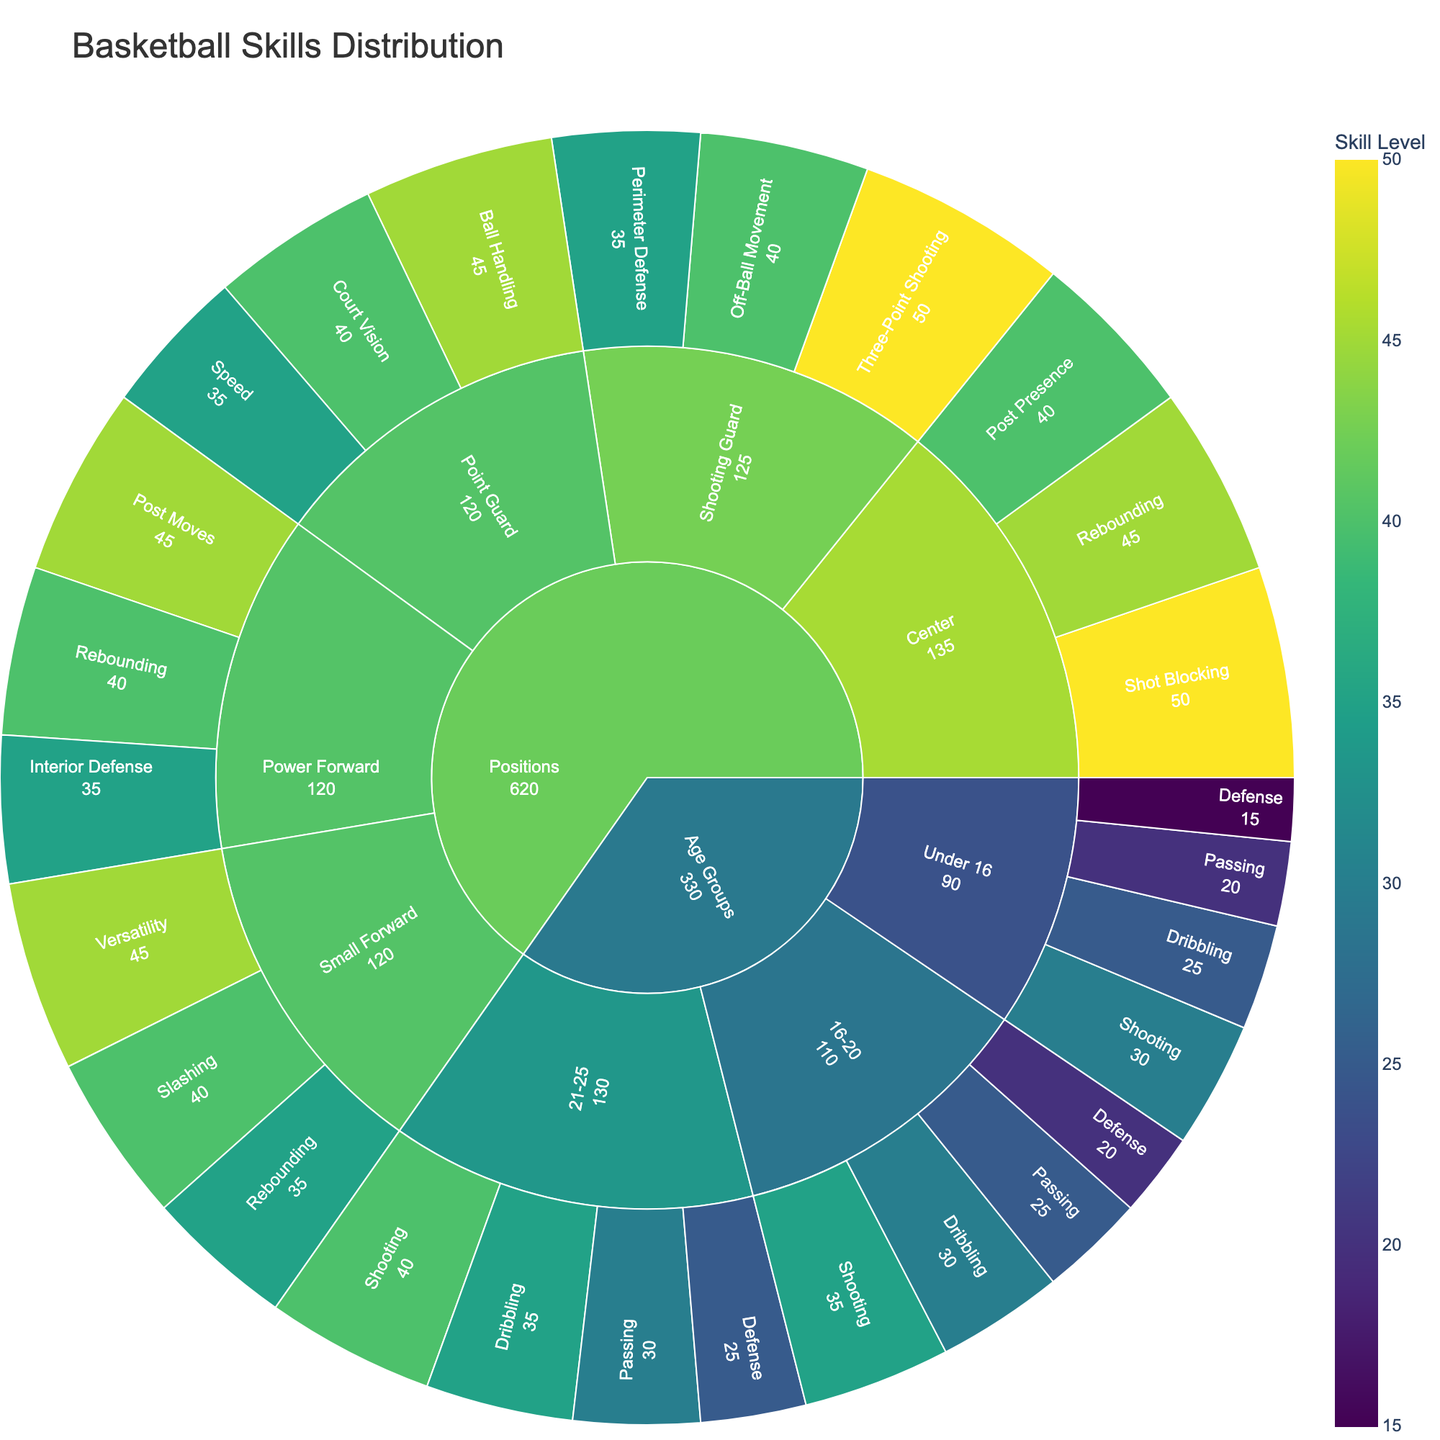what does the title of the plot indicate? The title of the plot says "Basketball Skills Distribution," which indicates that this plot provides information on how various basketball skills are distributed among players categorized by different age groups and positions.
Answer: Basketball Skills Distribution how many categories are represented in the sunburst plot? The sunburst plot is divided primarily into two main categories: Age Groups and Positions.
Answer: 2 which skill among centers has the highest skill level? By referring to the section for Centers within the Positions category, we see that Shot Blocking has the highest skill level of 50.
Answer: Shot Blocking what is the total skill value for players aged under 16? The skill values for players under 16 are Shooting (30), Dribbling (25), Passing (20), and Defense (15). Summing these values gives 30 + 25 + 20 + 15 = 90.
Answer: 90 how does the skill level of passing compare between players aged 16-20 and 21-25? The skill level for Passing is 25 for the 16-20 age group and 30 for the 21-25 age group. Thus, the 21-25 age group has a higher skill level in Passing by 5 units.
Answer: 21-25 has 5 more which position has the highest combined skill level for its top three skills? For each position, sum the top three skill levels:
Point Guard: Ball Handling (45) + Court Vision (40) + Speed (35) = 120
Shooting Guard: Three-Point Shooting (50) + Off-Ball Movement (40) + Perimeter Defense (35) = 125
Small Forward: Versatility (45) + Slashing (40) + Rebounding (35) = 120
Power Forward: Post Moves (45) + Rebounding (40) + Interior Defense (35) = 120
Center: Shot Blocking (50) + Rebounding (45) + Post Presence (40) = 135
The Center position has the highest combined skill level of 135.
Answer: Center what is the difference in the total skill value between point guards and shooting guards? Summing the skill values for Point Guards: Ball Handling (45) + Court Vision (40) + Speed (35) = 120. For Shooting Guards: Three-Point Shooting (50) + Off-Ball Movement (40) + Perimeter Defense (35) = 125. The difference is 125 - 120 = 5.
Answer: 5 how do the skill levels for rebounding compare across different positions? Rebounding skill levels are found for three positions: 
Small Forward (35), Power Forward (40), and Center (45). 
The Center position has the highest skill level in Rebounding, followed by Power Forward, and then Small Forward.
Answer: Center > Power Forward > Small Forward which age group has the lowest skill level in defense? Within the Age Groups category for Defense, the values are: 
Under 16 (15), 16-20 (20), and 21-25 (25). 
The Under 16 age group has the lowest skill level in Defense with a value of 15.
Answer: Under 16 which position has the highest skill level in court vision? Court Vision is a specific skill under the Point Guard position within the Positions category; it has a value of 40. Therefore, Point Guard has the highest skill level in Court Vision.
Answer: Point Guard 